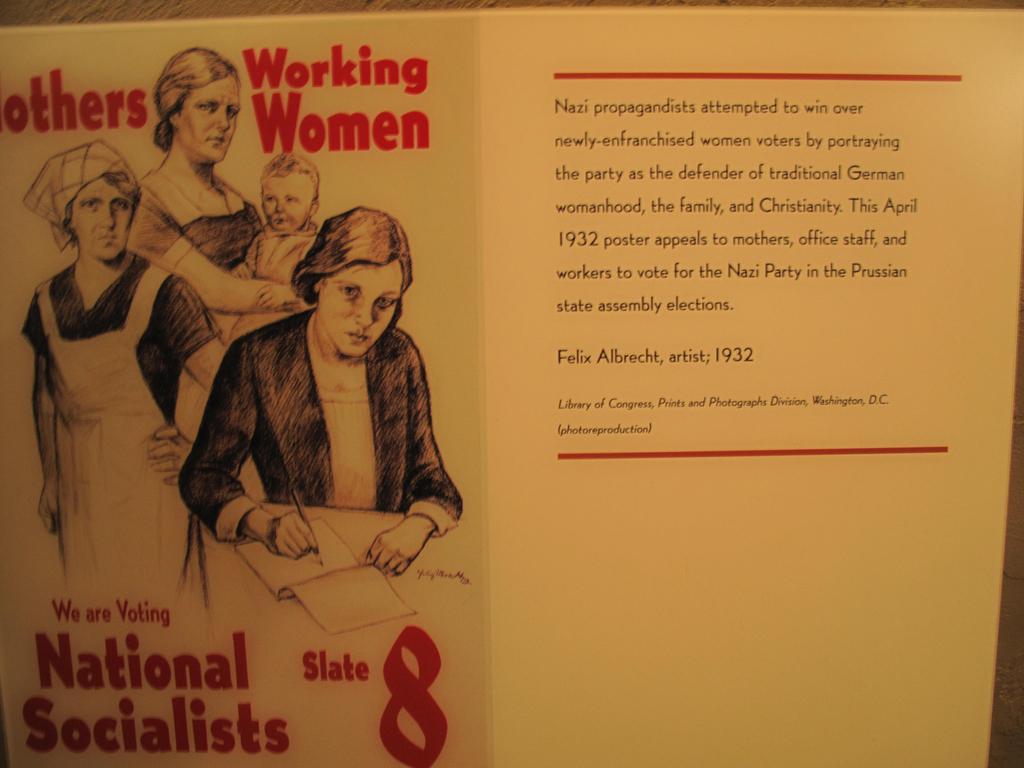In one or two sentences, can you explain what this image depicts? This image contains a poster having painting of few persons and some text on it. On poster there is painting of a woman carrying a baby in her arms and a woman is writing on a paper with a pen are on it. 